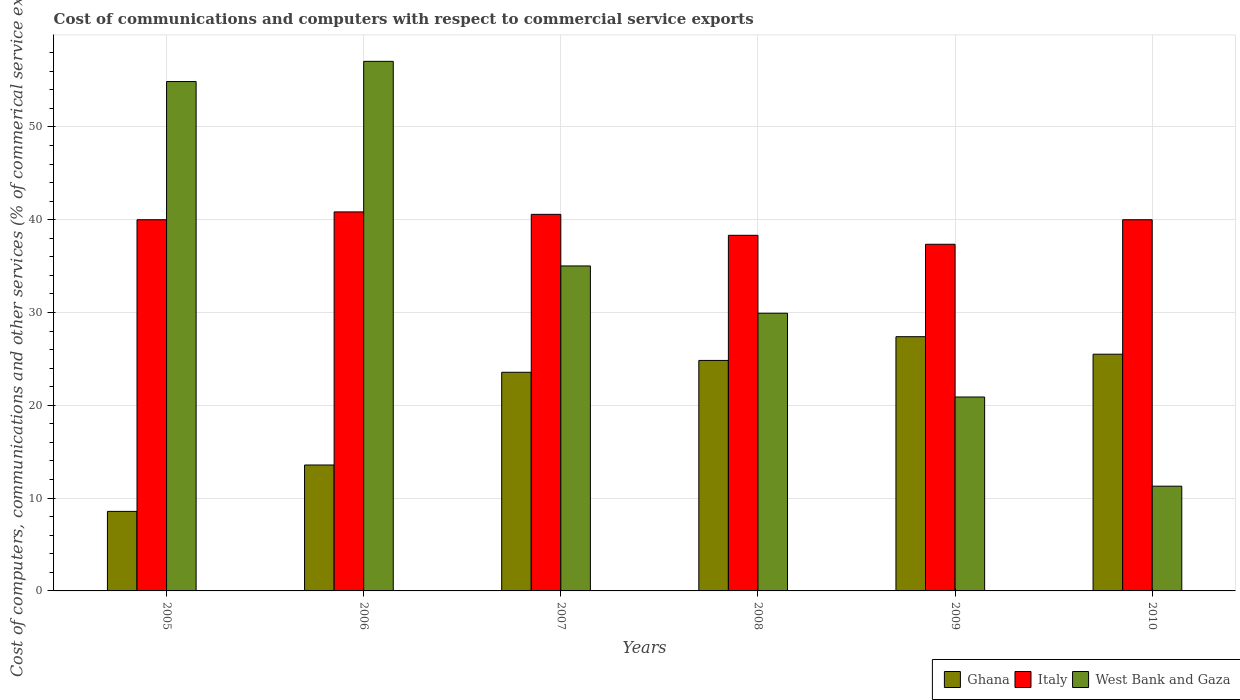How many different coloured bars are there?
Make the answer very short. 3. Are the number of bars per tick equal to the number of legend labels?
Offer a terse response. Yes. Are the number of bars on each tick of the X-axis equal?
Your answer should be very brief. Yes. How many bars are there on the 6th tick from the right?
Make the answer very short. 3. What is the label of the 6th group of bars from the left?
Make the answer very short. 2010. In how many cases, is the number of bars for a given year not equal to the number of legend labels?
Ensure brevity in your answer.  0. What is the cost of communications and computers in Italy in 2010?
Ensure brevity in your answer.  40. Across all years, what is the maximum cost of communications and computers in Italy?
Provide a succinct answer. 40.84. Across all years, what is the minimum cost of communications and computers in West Bank and Gaza?
Provide a succinct answer. 11.29. In which year was the cost of communications and computers in Italy minimum?
Your answer should be compact. 2009. What is the total cost of communications and computers in West Bank and Gaza in the graph?
Provide a short and direct response. 209.07. What is the difference between the cost of communications and computers in Italy in 2005 and that in 2007?
Provide a succinct answer. -0.58. What is the difference between the cost of communications and computers in Italy in 2007 and the cost of communications and computers in Ghana in 2010?
Your answer should be compact. 15.07. What is the average cost of communications and computers in Italy per year?
Offer a terse response. 39.51. In the year 2005, what is the difference between the cost of communications and computers in Ghana and cost of communications and computers in Italy?
Keep it short and to the point. -31.43. In how many years, is the cost of communications and computers in Italy greater than 12 %?
Keep it short and to the point. 6. What is the ratio of the cost of communications and computers in Ghana in 2006 to that in 2009?
Keep it short and to the point. 0.5. Is the cost of communications and computers in Ghana in 2008 less than that in 2009?
Offer a terse response. Yes. Is the difference between the cost of communications and computers in Ghana in 2008 and 2009 greater than the difference between the cost of communications and computers in Italy in 2008 and 2009?
Offer a terse response. No. What is the difference between the highest and the second highest cost of communications and computers in West Bank and Gaza?
Your answer should be very brief. 2.17. What is the difference between the highest and the lowest cost of communications and computers in Italy?
Your answer should be compact. 3.49. In how many years, is the cost of communications and computers in Ghana greater than the average cost of communications and computers in Ghana taken over all years?
Give a very brief answer. 4. Is the sum of the cost of communications and computers in West Bank and Gaza in 2008 and 2010 greater than the maximum cost of communications and computers in Ghana across all years?
Offer a very short reply. Yes. What does the 3rd bar from the left in 2006 represents?
Offer a very short reply. West Bank and Gaza. What does the 3rd bar from the right in 2009 represents?
Keep it short and to the point. Ghana. Is it the case that in every year, the sum of the cost of communications and computers in Italy and cost of communications and computers in West Bank and Gaza is greater than the cost of communications and computers in Ghana?
Your answer should be compact. Yes. How many bars are there?
Give a very brief answer. 18. What is the difference between two consecutive major ticks on the Y-axis?
Your answer should be compact. 10. Does the graph contain any zero values?
Offer a terse response. No. Does the graph contain grids?
Your answer should be compact. Yes. How many legend labels are there?
Your answer should be compact. 3. What is the title of the graph?
Provide a succinct answer. Cost of communications and computers with respect to commercial service exports. Does "San Marino" appear as one of the legend labels in the graph?
Ensure brevity in your answer.  No. What is the label or title of the X-axis?
Make the answer very short. Years. What is the label or title of the Y-axis?
Ensure brevity in your answer.  Cost of computers, communications and other services (% of commerical service exports). What is the Cost of computers, communications and other services (% of commerical service exports) of Ghana in 2005?
Your response must be concise. 8.57. What is the Cost of computers, communications and other services (% of commerical service exports) of Italy in 2005?
Make the answer very short. 40. What is the Cost of computers, communications and other services (% of commerical service exports) in West Bank and Gaza in 2005?
Give a very brief answer. 54.89. What is the Cost of computers, communications and other services (% of commerical service exports) of Ghana in 2006?
Your answer should be compact. 13.57. What is the Cost of computers, communications and other services (% of commerical service exports) in Italy in 2006?
Provide a short and direct response. 40.84. What is the Cost of computers, communications and other services (% of commerical service exports) of West Bank and Gaza in 2006?
Offer a terse response. 57.06. What is the Cost of computers, communications and other services (% of commerical service exports) in Ghana in 2007?
Offer a very short reply. 23.56. What is the Cost of computers, communications and other services (% of commerical service exports) in Italy in 2007?
Keep it short and to the point. 40.58. What is the Cost of computers, communications and other services (% of commerical service exports) in West Bank and Gaza in 2007?
Make the answer very short. 35.02. What is the Cost of computers, communications and other services (% of commerical service exports) of Ghana in 2008?
Make the answer very short. 24.84. What is the Cost of computers, communications and other services (% of commerical service exports) in Italy in 2008?
Make the answer very short. 38.32. What is the Cost of computers, communications and other services (% of commerical service exports) in West Bank and Gaza in 2008?
Ensure brevity in your answer.  29.92. What is the Cost of computers, communications and other services (% of commerical service exports) of Ghana in 2009?
Keep it short and to the point. 27.39. What is the Cost of computers, communications and other services (% of commerical service exports) in Italy in 2009?
Make the answer very short. 37.35. What is the Cost of computers, communications and other services (% of commerical service exports) of West Bank and Gaza in 2009?
Provide a short and direct response. 20.89. What is the Cost of computers, communications and other services (% of commerical service exports) of Ghana in 2010?
Make the answer very short. 25.51. What is the Cost of computers, communications and other services (% of commerical service exports) in Italy in 2010?
Provide a short and direct response. 40. What is the Cost of computers, communications and other services (% of commerical service exports) in West Bank and Gaza in 2010?
Offer a terse response. 11.29. Across all years, what is the maximum Cost of computers, communications and other services (% of commerical service exports) of Ghana?
Offer a terse response. 27.39. Across all years, what is the maximum Cost of computers, communications and other services (% of commerical service exports) in Italy?
Your answer should be very brief. 40.84. Across all years, what is the maximum Cost of computers, communications and other services (% of commerical service exports) of West Bank and Gaza?
Offer a terse response. 57.06. Across all years, what is the minimum Cost of computers, communications and other services (% of commerical service exports) of Ghana?
Your answer should be compact. 8.57. Across all years, what is the minimum Cost of computers, communications and other services (% of commerical service exports) in Italy?
Give a very brief answer. 37.35. Across all years, what is the minimum Cost of computers, communications and other services (% of commerical service exports) of West Bank and Gaza?
Your answer should be very brief. 11.29. What is the total Cost of computers, communications and other services (% of commerical service exports) in Ghana in the graph?
Give a very brief answer. 123.44. What is the total Cost of computers, communications and other services (% of commerical service exports) of Italy in the graph?
Make the answer very short. 237.08. What is the total Cost of computers, communications and other services (% of commerical service exports) in West Bank and Gaza in the graph?
Provide a succinct answer. 209.07. What is the difference between the Cost of computers, communications and other services (% of commerical service exports) of Ghana in 2005 and that in 2006?
Keep it short and to the point. -5. What is the difference between the Cost of computers, communications and other services (% of commerical service exports) of Italy in 2005 and that in 2006?
Ensure brevity in your answer.  -0.84. What is the difference between the Cost of computers, communications and other services (% of commerical service exports) in West Bank and Gaza in 2005 and that in 2006?
Give a very brief answer. -2.17. What is the difference between the Cost of computers, communications and other services (% of commerical service exports) in Ghana in 2005 and that in 2007?
Ensure brevity in your answer.  -14.99. What is the difference between the Cost of computers, communications and other services (% of commerical service exports) in Italy in 2005 and that in 2007?
Your answer should be very brief. -0.58. What is the difference between the Cost of computers, communications and other services (% of commerical service exports) of West Bank and Gaza in 2005 and that in 2007?
Your answer should be very brief. 19.87. What is the difference between the Cost of computers, communications and other services (% of commerical service exports) in Ghana in 2005 and that in 2008?
Offer a very short reply. -16.27. What is the difference between the Cost of computers, communications and other services (% of commerical service exports) in Italy in 2005 and that in 2008?
Give a very brief answer. 1.68. What is the difference between the Cost of computers, communications and other services (% of commerical service exports) in West Bank and Gaza in 2005 and that in 2008?
Your response must be concise. 24.97. What is the difference between the Cost of computers, communications and other services (% of commerical service exports) of Ghana in 2005 and that in 2009?
Provide a succinct answer. -18.82. What is the difference between the Cost of computers, communications and other services (% of commerical service exports) of Italy in 2005 and that in 2009?
Provide a succinct answer. 2.64. What is the difference between the Cost of computers, communications and other services (% of commerical service exports) of West Bank and Gaza in 2005 and that in 2009?
Your answer should be very brief. 33.99. What is the difference between the Cost of computers, communications and other services (% of commerical service exports) of Ghana in 2005 and that in 2010?
Offer a terse response. -16.93. What is the difference between the Cost of computers, communications and other services (% of commerical service exports) of Italy in 2005 and that in 2010?
Offer a very short reply. 0. What is the difference between the Cost of computers, communications and other services (% of commerical service exports) in West Bank and Gaza in 2005 and that in 2010?
Ensure brevity in your answer.  43.6. What is the difference between the Cost of computers, communications and other services (% of commerical service exports) in Ghana in 2006 and that in 2007?
Provide a short and direct response. -9.99. What is the difference between the Cost of computers, communications and other services (% of commerical service exports) in Italy in 2006 and that in 2007?
Ensure brevity in your answer.  0.26. What is the difference between the Cost of computers, communications and other services (% of commerical service exports) in West Bank and Gaza in 2006 and that in 2007?
Offer a very short reply. 22.05. What is the difference between the Cost of computers, communications and other services (% of commerical service exports) of Ghana in 2006 and that in 2008?
Offer a terse response. -11.27. What is the difference between the Cost of computers, communications and other services (% of commerical service exports) in Italy in 2006 and that in 2008?
Your response must be concise. 2.52. What is the difference between the Cost of computers, communications and other services (% of commerical service exports) of West Bank and Gaza in 2006 and that in 2008?
Provide a succinct answer. 27.14. What is the difference between the Cost of computers, communications and other services (% of commerical service exports) of Ghana in 2006 and that in 2009?
Your answer should be compact. -13.83. What is the difference between the Cost of computers, communications and other services (% of commerical service exports) of Italy in 2006 and that in 2009?
Offer a terse response. 3.49. What is the difference between the Cost of computers, communications and other services (% of commerical service exports) of West Bank and Gaza in 2006 and that in 2009?
Your answer should be very brief. 36.17. What is the difference between the Cost of computers, communications and other services (% of commerical service exports) in Ghana in 2006 and that in 2010?
Make the answer very short. -11.94. What is the difference between the Cost of computers, communications and other services (% of commerical service exports) in Italy in 2006 and that in 2010?
Provide a short and direct response. 0.84. What is the difference between the Cost of computers, communications and other services (% of commerical service exports) in West Bank and Gaza in 2006 and that in 2010?
Offer a terse response. 45.78. What is the difference between the Cost of computers, communications and other services (% of commerical service exports) of Ghana in 2007 and that in 2008?
Your answer should be compact. -1.28. What is the difference between the Cost of computers, communications and other services (% of commerical service exports) in Italy in 2007 and that in 2008?
Make the answer very short. 2.26. What is the difference between the Cost of computers, communications and other services (% of commerical service exports) of West Bank and Gaza in 2007 and that in 2008?
Your answer should be compact. 5.09. What is the difference between the Cost of computers, communications and other services (% of commerical service exports) in Ghana in 2007 and that in 2009?
Your answer should be very brief. -3.83. What is the difference between the Cost of computers, communications and other services (% of commerical service exports) in Italy in 2007 and that in 2009?
Provide a short and direct response. 3.22. What is the difference between the Cost of computers, communications and other services (% of commerical service exports) in West Bank and Gaza in 2007 and that in 2009?
Offer a terse response. 14.12. What is the difference between the Cost of computers, communications and other services (% of commerical service exports) of Ghana in 2007 and that in 2010?
Offer a very short reply. -1.95. What is the difference between the Cost of computers, communications and other services (% of commerical service exports) of Italy in 2007 and that in 2010?
Your response must be concise. 0.58. What is the difference between the Cost of computers, communications and other services (% of commerical service exports) of West Bank and Gaza in 2007 and that in 2010?
Offer a very short reply. 23.73. What is the difference between the Cost of computers, communications and other services (% of commerical service exports) of Ghana in 2008 and that in 2009?
Keep it short and to the point. -2.56. What is the difference between the Cost of computers, communications and other services (% of commerical service exports) in Italy in 2008 and that in 2009?
Ensure brevity in your answer.  0.97. What is the difference between the Cost of computers, communications and other services (% of commerical service exports) of West Bank and Gaza in 2008 and that in 2009?
Your answer should be compact. 9.03. What is the difference between the Cost of computers, communications and other services (% of commerical service exports) in Ghana in 2008 and that in 2010?
Make the answer very short. -0.67. What is the difference between the Cost of computers, communications and other services (% of commerical service exports) in Italy in 2008 and that in 2010?
Offer a terse response. -1.68. What is the difference between the Cost of computers, communications and other services (% of commerical service exports) in West Bank and Gaza in 2008 and that in 2010?
Your answer should be very brief. 18.64. What is the difference between the Cost of computers, communications and other services (% of commerical service exports) of Ghana in 2009 and that in 2010?
Offer a terse response. 1.89. What is the difference between the Cost of computers, communications and other services (% of commerical service exports) in Italy in 2009 and that in 2010?
Keep it short and to the point. -2.64. What is the difference between the Cost of computers, communications and other services (% of commerical service exports) of West Bank and Gaza in 2009 and that in 2010?
Your answer should be compact. 9.61. What is the difference between the Cost of computers, communications and other services (% of commerical service exports) in Ghana in 2005 and the Cost of computers, communications and other services (% of commerical service exports) in Italy in 2006?
Provide a succinct answer. -32.27. What is the difference between the Cost of computers, communications and other services (% of commerical service exports) in Ghana in 2005 and the Cost of computers, communications and other services (% of commerical service exports) in West Bank and Gaza in 2006?
Give a very brief answer. -48.49. What is the difference between the Cost of computers, communications and other services (% of commerical service exports) in Italy in 2005 and the Cost of computers, communications and other services (% of commerical service exports) in West Bank and Gaza in 2006?
Make the answer very short. -17.07. What is the difference between the Cost of computers, communications and other services (% of commerical service exports) in Ghana in 2005 and the Cost of computers, communications and other services (% of commerical service exports) in Italy in 2007?
Ensure brevity in your answer.  -32.01. What is the difference between the Cost of computers, communications and other services (% of commerical service exports) in Ghana in 2005 and the Cost of computers, communications and other services (% of commerical service exports) in West Bank and Gaza in 2007?
Ensure brevity in your answer.  -26.45. What is the difference between the Cost of computers, communications and other services (% of commerical service exports) in Italy in 2005 and the Cost of computers, communications and other services (% of commerical service exports) in West Bank and Gaza in 2007?
Provide a succinct answer. 4.98. What is the difference between the Cost of computers, communications and other services (% of commerical service exports) in Ghana in 2005 and the Cost of computers, communications and other services (% of commerical service exports) in Italy in 2008?
Provide a short and direct response. -29.75. What is the difference between the Cost of computers, communications and other services (% of commerical service exports) in Ghana in 2005 and the Cost of computers, communications and other services (% of commerical service exports) in West Bank and Gaza in 2008?
Offer a terse response. -21.35. What is the difference between the Cost of computers, communications and other services (% of commerical service exports) of Italy in 2005 and the Cost of computers, communications and other services (% of commerical service exports) of West Bank and Gaza in 2008?
Offer a very short reply. 10.07. What is the difference between the Cost of computers, communications and other services (% of commerical service exports) of Ghana in 2005 and the Cost of computers, communications and other services (% of commerical service exports) of Italy in 2009?
Keep it short and to the point. -28.78. What is the difference between the Cost of computers, communications and other services (% of commerical service exports) of Ghana in 2005 and the Cost of computers, communications and other services (% of commerical service exports) of West Bank and Gaza in 2009?
Keep it short and to the point. -12.32. What is the difference between the Cost of computers, communications and other services (% of commerical service exports) in Italy in 2005 and the Cost of computers, communications and other services (% of commerical service exports) in West Bank and Gaza in 2009?
Offer a very short reply. 19.1. What is the difference between the Cost of computers, communications and other services (% of commerical service exports) of Ghana in 2005 and the Cost of computers, communications and other services (% of commerical service exports) of Italy in 2010?
Your response must be concise. -31.42. What is the difference between the Cost of computers, communications and other services (% of commerical service exports) of Ghana in 2005 and the Cost of computers, communications and other services (% of commerical service exports) of West Bank and Gaza in 2010?
Your response must be concise. -2.71. What is the difference between the Cost of computers, communications and other services (% of commerical service exports) of Italy in 2005 and the Cost of computers, communications and other services (% of commerical service exports) of West Bank and Gaza in 2010?
Your answer should be very brief. 28.71. What is the difference between the Cost of computers, communications and other services (% of commerical service exports) of Ghana in 2006 and the Cost of computers, communications and other services (% of commerical service exports) of Italy in 2007?
Your answer should be very brief. -27.01. What is the difference between the Cost of computers, communications and other services (% of commerical service exports) in Ghana in 2006 and the Cost of computers, communications and other services (% of commerical service exports) in West Bank and Gaza in 2007?
Your response must be concise. -21.45. What is the difference between the Cost of computers, communications and other services (% of commerical service exports) of Italy in 2006 and the Cost of computers, communications and other services (% of commerical service exports) of West Bank and Gaza in 2007?
Provide a succinct answer. 5.82. What is the difference between the Cost of computers, communications and other services (% of commerical service exports) in Ghana in 2006 and the Cost of computers, communications and other services (% of commerical service exports) in Italy in 2008?
Your answer should be compact. -24.75. What is the difference between the Cost of computers, communications and other services (% of commerical service exports) in Ghana in 2006 and the Cost of computers, communications and other services (% of commerical service exports) in West Bank and Gaza in 2008?
Offer a very short reply. -16.35. What is the difference between the Cost of computers, communications and other services (% of commerical service exports) of Italy in 2006 and the Cost of computers, communications and other services (% of commerical service exports) of West Bank and Gaza in 2008?
Offer a terse response. 10.92. What is the difference between the Cost of computers, communications and other services (% of commerical service exports) in Ghana in 2006 and the Cost of computers, communications and other services (% of commerical service exports) in Italy in 2009?
Make the answer very short. -23.78. What is the difference between the Cost of computers, communications and other services (% of commerical service exports) of Ghana in 2006 and the Cost of computers, communications and other services (% of commerical service exports) of West Bank and Gaza in 2009?
Keep it short and to the point. -7.33. What is the difference between the Cost of computers, communications and other services (% of commerical service exports) of Italy in 2006 and the Cost of computers, communications and other services (% of commerical service exports) of West Bank and Gaza in 2009?
Your response must be concise. 19.95. What is the difference between the Cost of computers, communications and other services (% of commerical service exports) of Ghana in 2006 and the Cost of computers, communications and other services (% of commerical service exports) of Italy in 2010?
Your answer should be compact. -26.43. What is the difference between the Cost of computers, communications and other services (% of commerical service exports) in Ghana in 2006 and the Cost of computers, communications and other services (% of commerical service exports) in West Bank and Gaza in 2010?
Give a very brief answer. 2.28. What is the difference between the Cost of computers, communications and other services (% of commerical service exports) in Italy in 2006 and the Cost of computers, communications and other services (% of commerical service exports) in West Bank and Gaza in 2010?
Offer a terse response. 29.55. What is the difference between the Cost of computers, communications and other services (% of commerical service exports) of Ghana in 2007 and the Cost of computers, communications and other services (% of commerical service exports) of Italy in 2008?
Provide a short and direct response. -14.76. What is the difference between the Cost of computers, communications and other services (% of commerical service exports) of Ghana in 2007 and the Cost of computers, communications and other services (% of commerical service exports) of West Bank and Gaza in 2008?
Provide a short and direct response. -6.36. What is the difference between the Cost of computers, communications and other services (% of commerical service exports) in Italy in 2007 and the Cost of computers, communications and other services (% of commerical service exports) in West Bank and Gaza in 2008?
Ensure brevity in your answer.  10.65. What is the difference between the Cost of computers, communications and other services (% of commerical service exports) of Ghana in 2007 and the Cost of computers, communications and other services (% of commerical service exports) of Italy in 2009?
Your answer should be very brief. -13.79. What is the difference between the Cost of computers, communications and other services (% of commerical service exports) in Ghana in 2007 and the Cost of computers, communications and other services (% of commerical service exports) in West Bank and Gaza in 2009?
Offer a terse response. 2.67. What is the difference between the Cost of computers, communications and other services (% of commerical service exports) in Italy in 2007 and the Cost of computers, communications and other services (% of commerical service exports) in West Bank and Gaza in 2009?
Ensure brevity in your answer.  19.68. What is the difference between the Cost of computers, communications and other services (% of commerical service exports) of Ghana in 2007 and the Cost of computers, communications and other services (% of commerical service exports) of Italy in 2010?
Provide a short and direct response. -16.44. What is the difference between the Cost of computers, communications and other services (% of commerical service exports) in Ghana in 2007 and the Cost of computers, communications and other services (% of commerical service exports) in West Bank and Gaza in 2010?
Offer a very short reply. 12.27. What is the difference between the Cost of computers, communications and other services (% of commerical service exports) of Italy in 2007 and the Cost of computers, communications and other services (% of commerical service exports) of West Bank and Gaza in 2010?
Offer a very short reply. 29.29. What is the difference between the Cost of computers, communications and other services (% of commerical service exports) in Ghana in 2008 and the Cost of computers, communications and other services (% of commerical service exports) in Italy in 2009?
Provide a succinct answer. -12.52. What is the difference between the Cost of computers, communications and other services (% of commerical service exports) in Ghana in 2008 and the Cost of computers, communications and other services (% of commerical service exports) in West Bank and Gaza in 2009?
Your answer should be very brief. 3.94. What is the difference between the Cost of computers, communications and other services (% of commerical service exports) in Italy in 2008 and the Cost of computers, communications and other services (% of commerical service exports) in West Bank and Gaza in 2009?
Provide a succinct answer. 17.42. What is the difference between the Cost of computers, communications and other services (% of commerical service exports) of Ghana in 2008 and the Cost of computers, communications and other services (% of commerical service exports) of Italy in 2010?
Offer a terse response. -15.16. What is the difference between the Cost of computers, communications and other services (% of commerical service exports) in Ghana in 2008 and the Cost of computers, communications and other services (% of commerical service exports) in West Bank and Gaza in 2010?
Your response must be concise. 13.55. What is the difference between the Cost of computers, communications and other services (% of commerical service exports) in Italy in 2008 and the Cost of computers, communications and other services (% of commerical service exports) in West Bank and Gaza in 2010?
Offer a very short reply. 27.03. What is the difference between the Cost of computers, communications and other services (% of commerical service exports) of Ghana in 2009 and the Cost of computers, communications and other services (% of commerical service exports) of Italy in 2010?
Offer a terse response. -12.6. What is the difference between the Cost of computers, communications and other services (% of commerical service exports) in Ghana in 2009 and the Cost of computers, communications and other services (% of commerical service exports) in West Bank and Gaza in 2010?
Your answer should be very brief. 16.11. What is the difference between the Cost of computers, communications and other services (% of commerical service exports) in Italy in 2009 and the Cost of computers, communications and other services (% of commerical service exports) in West Bank and Gaza in 2010?
Make the answer very short. 26.07. What is the average Cost of computers, communications and other services (% of commerical service exports) in Ghana per year?
Keep it short and to the point. 20.57. What is the average Cost of computers, communications and other services (% of commerical service exports) in Italy per year?
Ensure brevity in your answer.  39.51. What is the average Cost of computers, communications and other services (% of commerical service exports) of West Bank and Gaza per year?
Your answer should be compact. 34.84. In the year 2005, what is the difference between the Cost of computers, communications and other services (% of commerical service exports) in Ghana and Cost of computers, communications and other services (% of commerical service exports) in Italy?
Your answer should be very brief. -31.43. In the year 2005, what is the difference between the Cost of computers, communications and other services (% of commerical service exports) of Ghana and Cost of computers, communications and other services (% of commerical service exports) of West Bank and Gaza?
Make the answer very short. -46.32. In the year 2005, what is the difference between the Cost of computers, communications and other services (% of commerical service exports) of Italy and Cost of computers, communications and other services (% of commerical service exports) of West Bank and Gaza?
Keep it short and to the point. -14.89. In the year 2006, what is the difference between the Cost of computers, communications and other services (% of commerical service exports) in Ghana and Cost of computers, communications and other services (% of commerical service exports) in Italy?
Make the answer very short. -27.27. In the year 2006, what is the difference between the Cost of computers, communications and other services (% of commerical service exports) of Ghana and Cost of computers, communications and other services (% of commerical service exports) of West Bank and Gaza?
Your answer should be compact. -43.49. In the year 2006, what is the difference between the Cost of computers, communications and other services (% of commerical service exports) of Italy and Cost of computers, communications and other services (% of commerical service exports) of West Bank and Gaza?
Ensure brevity in your answer.  -16.22. In the year 2007, what is the difference between the Cost of computers, communications and other services (% of commerical service exports) of Ghana and Cost of computers, communications and other services (% of commerical service exports) of Italy?
Keep it short and to the point. -17.02. In the year 2007, what is the difference between the Cost of computers, communications and other services (% of commerical service exports) of Ghana and Cost of computers, communications and other services (% of commerical service exports) of West Bank and Gaza?
Make the answer very short. -11.46. In the year 2007, what is the difference between the Cost of computers, communications and other services (% of commerical service exports) in Italy and Cost of computers, communications and other services (% of commerical service exports) in West Bank and Gaza?
Your answer should be compact. 5.56. In the year 2008, what is the difference between the Cost of computers, communications and other services (% of commerical service exports) of Ghana and Cost of computers, communications and other services (% of commerical service exports) of Italy?
Provide a succinct answer. -13.48. In the year 2008, what is the difference between the Cost of computers, communications and other services (% of commerical service exports) of Ghana and Cost of computers, communications and other services (% of commerical service exports) of West Bank and Gaza?
Offer a very short reply. -5.08. In the year 2008, what is the difference between the Cost of computers, communications and other services (% of commerical service exports) in Italy and Cost of computers, communications and other services (% of commerical service exports) in West Bank and Gaza?
Give a very brief answer. 8.4. In the year 2009, what is the difference between the Cost of computers, communications and other services (% of commerical service exports) of Ghana and Cost of computers, communications and other services (% of commerical service exports) of Italy?
Your response must be concise. -9.96. In the year 2009, what is the difference between the Cost of computers, communications and other services (% of commerical service exports) in Ghana and Cost of computers, communications and other services (% of commerical service exports) in West Bank and Gaza?
Ensure brevity in your answer.  6.5. In the year 2009, what is the difference between the Cost of computers, communications and other services (% of commerical service exports) in Italy and Cost of computers, communications and other services (% of commerical service exports) in West Bank and Gaza?
Offer a very short reply. 16.46. In the year 2010, what is the difference between the Cost of computers, communications and other services (% of commerical service exports) of Ghana and Cost of computers, communications and other services (% of commerical service exports) of Italy?
Offer a very short reply. -14.49. In the year 2010, what is the difference between the Cost of computers, communications and other services (% of commerical service exports) in Ghana and Cost of computers, communications and other services (% of commerical service exports) in West Bank and Gaza?
Offer a terse response. 14.22. In the year 2010, what is the difference between the Cost of computers, communications and other services (% of commerical service exports) of Italy and Cost of computers, communications and other services (% of commerical service exports) of West Bank and Gaza?
Your response must be concise. 28.71. What is the ratio of the Cost of computers, communications and other services (% of commerical service exports) of Ghana in 2005 to that in 2006?
Offer a very short reply. 0.63. What is the ratio of the Cost of computers, communications and other services (% of commerical service exports) of Italy in 2005 to that in 2006?
Provide a succinct answer. 0.98. What is the ratio of the Cost of computers, communications and other services (% of commerical service exports) of West Bank and Gaza in 2005 to that in 2006?
Make the answer very short. 0.96. What is the ratio of the Cost of computers, communications and other services (% of commerical service exports) in Ghana in 2005 to that in 2007?
Ensure brevity in your answer.  0.36. What is the ratio of the Cost of computers, communications and other services (% of commerical service exports) in Italy in 2005 to that in 2007?
Provide a succinct answer. 0.99. What is the ratio of the Cost of computers, communications and other services (% of commerical service exports) of West Bank and Gaza in 2005 to that in 2007?
Your response must be concise. 1.57. What is the ratio of the Cost of computers, communications and other services (% of commerical service exports) in Ghana in 2005 to that in 2008?
Make the answer very short. 0.35. What is the ratio of the Cost of computers, communications and other services (% of commerical service exports) in Italy in 2005 to that in 2008?
Give a very brief answer. 1.04. What is the ratio of the Cost of computers, communications and other services (% of commerical service exports) in West Bank and Gaza in 2005 to that in 2008?
Keep it short and to the point. 1.83. What is the ratio of the Cost of computers, communications and other services (% of commerical service exports) in Ghana in 2005 to that in 2009?
Make the answer very short. 0.31. What is the ratio of the Cost of computers, communications and other services (% of commerical service exports) of Italy in 2005 to that in 2009?
Keep it short and to the point. 1.07. What is the ratio of the Cost of computers, communications and other services (% of commerical service exports) of West Bank and Gaza in 2005 to that in 2009?
Offer a terse response. 2.63. What is the ratio of the Cost of computers, communications and other services (% of commerical service exports) in Ghana in 2005 to that in 2010?
Ensure brevity in your answer.  0.34. What is the ratio of the Cost of computers, communications and other services (% of commerical service exports) in Italy in 2005 to that in 2010?
Give a very brief answer. 1. What is the ratio of the Cost of computers, communications and other services (% of commerical service exports) in West Bank and Gaza in 2005 to that in 2010?
Give a very brief answer. 4.86. What is the ratio of the Cost of computers, communications and other services (% of commerical service exports) of Ghana in 2006 to that in 2007?
Your answer should be very brief. 0.58. What is the ratio of the Cost of computers, communications and other services (% of commerical service exports) of West Bank and Gaza in 2006 to that in 2007?
Give a very brief answer. 1.63. What is the ratio of the Cost of computers, communications and other services (% of commerical service exports) of Ghana in 2006 to that in 2008?
Provide a short and direct response. 0.55. What is the ratio of the Cost of computers, communications and other services (% of commerical service exports) in Italy in 2006 to that in 2008?
Your answer should be compact. 1.07. What is the ratio of the Cost of computers, communications and other services (% of commerical service exports) in West Bank and Gaza in 2006 to that in 2008?
Your response must be concise. 1.91. What is the ratio of the Cost of computers, communications and other services (% of commerical service exports) in Ghana in 2006 to that in 2009?
Ensure brevity in your answer.  0.5. What is the ratio of the Cost of computers, communications and other services (% of commerical service exports) in Italy in 2006 to that in 2009?
Your answer should be compact. 1.09. What is the ratio of the Cost of computers, communications and other services (% of commerical service exports) in West Bank and Gaza in 2006 to that in 2009?
Your answer should be compact. 2.73. What is the ratio of the Cost of computers, communications and other services (% of commerical service exports) in Ghana in 2006 to that in 2010?
Your response must be concise. 0.53. What is the ratio of the Cost of computers, communications and other services (% of commerical service exports) of Italy in 2006 to that in 2010?
Offer a very short reply. 1.02. What is the ratio of the Cost of computers, communications and other services (% of commerical service exports) in West Bank and Gaza in 2006 to that in 2010?
Make the answer very short. 5.06. What is the ratio of the Cost of computers, communications and other services (% of commerical service exports) in Ghana in 2007 to that in 2008?
Provide a short and direct response. 0.95. What is the ratio of the Cost of computers, communications and other services (% of commerical service exports) of Italy in 2007 to that in 2008?
Offer a very short reply. 1.06. What is the ratio of the Cost of computers, communications and other services (% of commerical service exports) in West Bank and Gaza in 2007 to that in 2008?
Your answer should be very brief. 1.17. What is the ratio of the Cost of computers, communications and other services (% of commerical service exports) in Ghana in 2007 to that in 2009?
Ensure brevity in your answer.  0.86. What is the ratio of the Cost of computers, communications and other services (% of commerical service exports) in Italy in 2007 to that in 2009?
Offer a very short reply. 1.09. What is the ratio of the Cost of computers, communications and other services (% of commerical service exports) in West Bank and Gaza in 2007 to that in 2009?
Your answer should be compact. 1.68. What is the ratio of the Cost of computers, communications and other services (% of commerical service exports) of Ghana in 2007 to that in 2010?
Your response must be concise. 0.92. What is the ratio of the Cost of computers, communications and other services (% of commerical service exports) in Italy in 2007 to that in 2010?
Give a very brief answer. 1.01. What is the ratio of the Cost of computers, communications and other services (% of commerical service exports) in West Bank and Gaza in 2007 to that in 2010?
Your response must be concise. 3.1. What is the ratio of the Cost of computers, communications and other services (% of commerical service exports) in Ghana in 2008 to that in 2009?
Your answer should be very brief. 0.91. What is the ratio of the Cost of computers, communications and other services (% of commerical service exports) of Italy in 2008 to that in 2009?
Offer a very short reply. 1.03. What is the ratio of the Cost of computers, communications and other services (% of commerical service exports) in West Bank and Gaza in 2008 to that in 2009?
Your answer should be very brief. 1.43. What is the ratio of the Cost of computers, communications and other services (% of commerical service exports) in Ghana in 2008 to that in 2010?
Your answer should be very brief. 0.97. What is the ratio of the Cost of computers, communications and other services (% of commerical service exports) of Italy in 2008 to that in 2010?
Offer a very short reply. 0.96. What is the ratio of the Cost of computers, communications and other services (% of commerical service exports) in West Bank and Gaza in 2008 to that in 2010?
Keep it short and to the point. 2.65. What is the ratio of the Cost of computers, communications and other services (% of commerical service exports) of Ghana in 2009 to that in 2010?
Your response must be concise. 1.07. What is the ratio of the Cost of computers, communications and other services (% of commerical service exports) in Italy in 2009 to that in 2010?
Provide a short and direct response. 0.93. What is the ratio of the Cost of computers, communications and other services (% of commerical service exports) of West Bank and Gaza in 2009 to that in 2010?
Give a very brief answer. 1.85. What is the difference between the highest and the second highest Cost of computers, communications and other services (% of commerical service exports) of Ghana?
Offer a terse response. 1.89. What is the difference between the highest and the second highest Cost of computers, communications and other services (% of commerical service exports) of Italy?
Your answer should be compact. 0.26. What is the difference between the highest and the second highest Cost of computers, communications and other services (% of commerical service exports) of West Bank and Gaza?
Your answer should be very brief. 2.17. What is the difference between the highest and the lowest Cost of computers, communications and other services (% of commerical service exports) in Ghana?
Offer a very short reply. 18.82. What is the difference between the highest and the lowest Cost of computers, communications and other services (% of commerical service exports) of Italy?
Ensure brevity in your answer.  3.49. What is the difference between the highest and the lowest Cost of computers, communications and other services (% of commerical service exports) of West Bank and Gaza?
Your response must be concise. 45.78. 